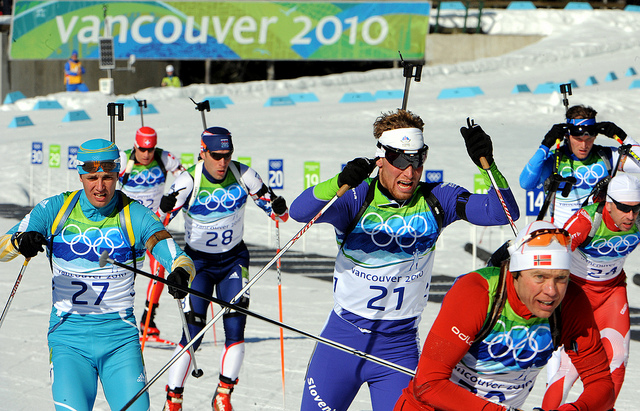Can you elaborate on the elements of the picture provided? The picture showcases a dynamic scene from a ski race event at the Vancouver 2010 Winter Olympics. The athletes are geared up for the competition with essential equipment and clothing. Protective goggles and sunglasses are used to shield their eyes from the snow and glare, visible across different areas of the image. The skiers are also wearing colorful headbands, likely indicating their team affiliations, which helps in both absorbing sweat and showcasing team colors. Ski poles are prominently featured, assisting the athletes in balance and propulsion, with many stretching vertically through the image. Additionally, some skiers are sporting specialized ski boots crucial for attaching to the skis. The atmosphere is intense, with the skiers fully focused on their performance in the race. 